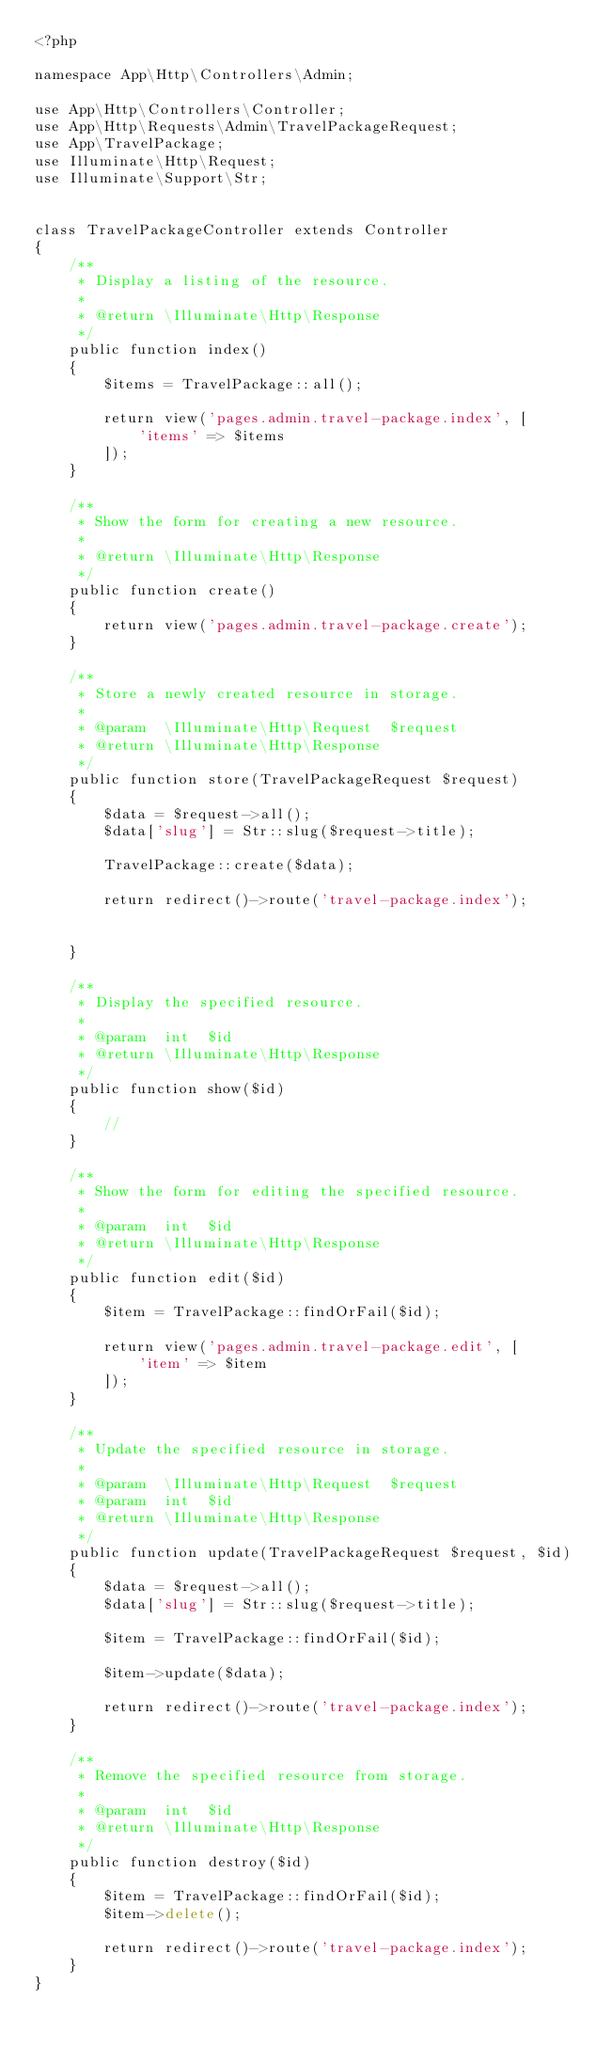<code> <loc_0><loc_0><loc_500><loc_500><_PHP_><?php

namespace App\Http\Controllers\Admin;

use App\Http\Controllers\Controller;
use App\Http\Requests\Admin\TravelPackageRequest;
use App\TravelPackage;
use Illuminate\Http\Request;
use Illuminate\Support\Str;


class TravelPackageController extends Controller
{
    /**
     * Display a listing of the resource.
     *
     * @return \Illuminate\Http\Response
     */
    public function index()
    {
        $items = TravelPackage::all();

        return view('pages.admin.travel-package.index', [
            'items' => $items 
        ]);
    }

    /**
     * Show the form for creating a new resource.
     *
     * @return \Illuminate\Http\Response
     */
    public function create()
    {
        return view('pages.admin.travel-package.create');
    }

    /**
     * Store a newly created resource in storage.
     *
     * @param  \Illuminate\Http\Request  $request
     * @return \Illuminate\Http\Response
     */
    public function store(TravelPackageRequest $request)
    {
        $data = $request->all();
        $data['slug'] = Str::slug($request->title);

        TravelPackage::create($data);

        return redirect()->route('travel-package.index');


    }

    /**
     * Display the specified resource.
     *
     * @param  int  $id
     * @return \Illuminate\Http\Response
     */
    public function show($id)
    {
        //
    }

    /**
     * Show the form for editing the specified resource.
     *
     * @param  int  $id
     * @return \Illuminate\Http\Response
     */
    public function edit($id)
    {
        $item = TravelPackage::findOrFail($id);

        return view('pages.admin.travel-package.edit', [
            'item' => $item
        ]);
    }

    /**
     * Update the specified resource in storage.
     *
     * @param  \Illuminate\Http\Request  $request
     * @param  int  $id
     * @return \Illuminate\Http\Response
     */
    public function update(TravelPackageRequest $request, $id)
    {
        $data = $request->all();
        $data['slug'] = Str::slug($request->title);

        $item = TravelPackage::findOrFail($id);

        $item->update($data);

        return redirect()->route('travel-package.index');
    }

    /**
     * Remove the specified resource from storage.
     *
     * @param  int  $id
     * @return \Illuminate\Http\Response
     */
    public function destroy($id)
    {
        $item = TravelPackage::findOrFail($id);
        $item->delete();

        return redirect()->route('travel-package.index');
    }
}
</code> 